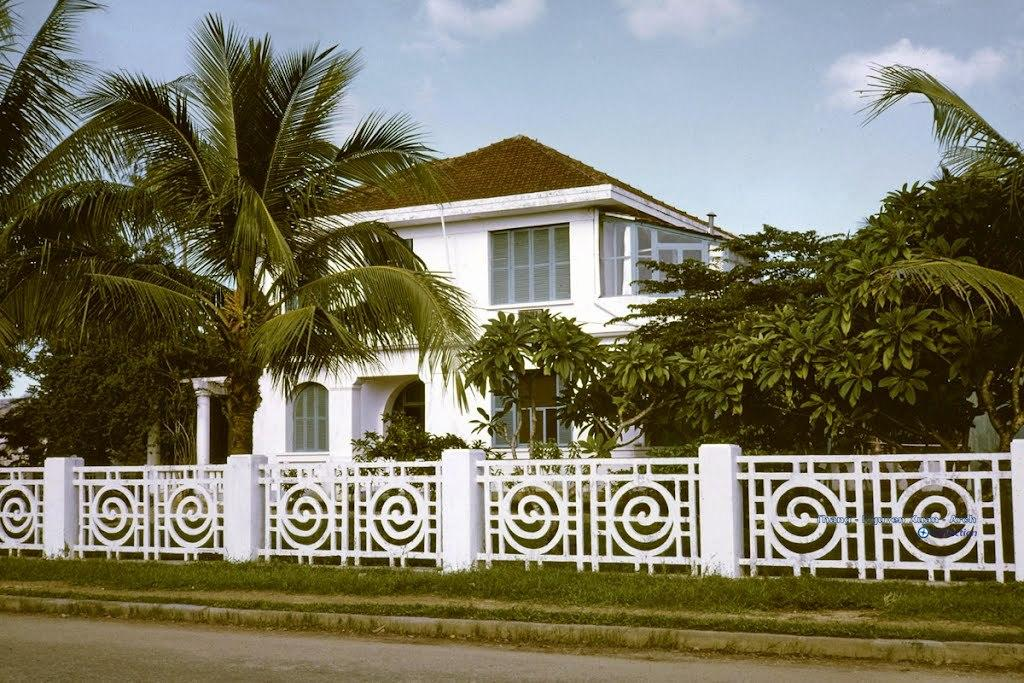What type of structure is visible in the image? There is a building in the image. What is located in front of the building? There are trees, a fence, grass, and a road in front of the building. What can be seen in the background of the image? The sky is visible in the background of the image. What is the taste of the silver wren in the image? There is no silver wren present in the image, and therefore no taste can be attributed to it. 